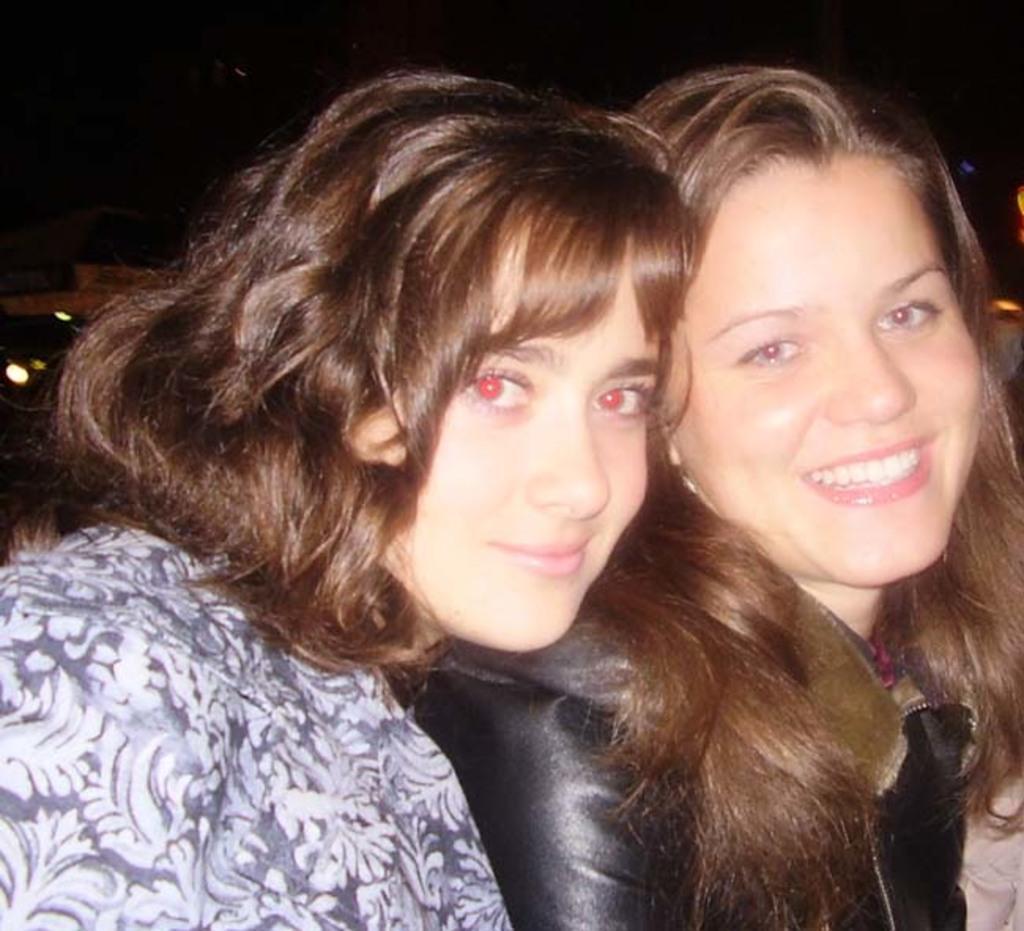In one or two sentences, can you explain what this image depicts? In this image there are two women with a smile on their face. 